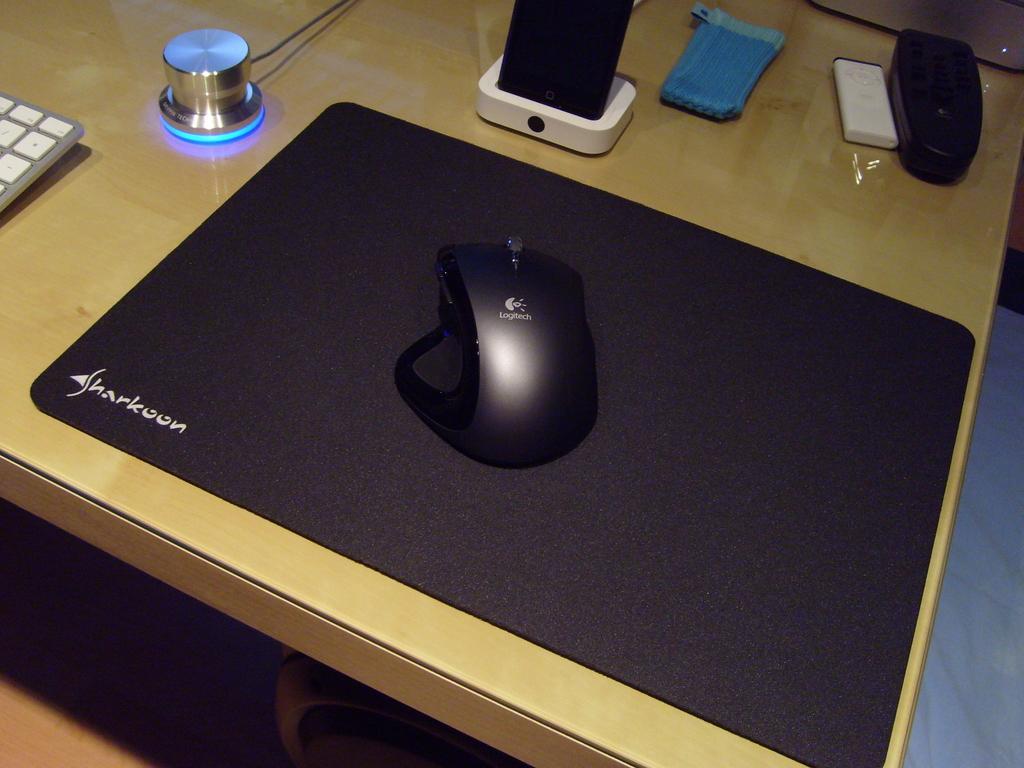In one or two sentences, can you explain what this image depicts? In this picture, we see a wooden table on which a mouse, keyboard, mouse pad, speaker, objects in white and blue color and some other objects are placed. 